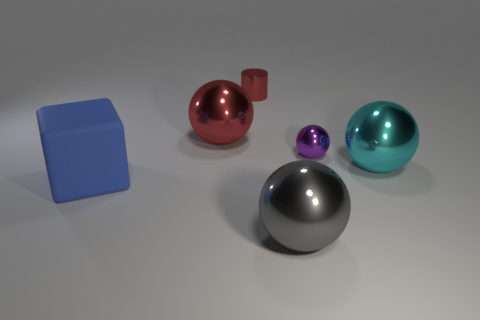Subtract all brown balls. Subtract all cyan cylinders. How many balls are left? 4 Add 1 small cyan matte things. How many objects exist? 7 Subtract all spheres. How many objects are left? 2 Add 6 big red spheres. How many big red spheres are left? 7 Add 3 tiny yellow metal spheres. How many tiny yellow metal spheres exist? 3 Subtract 0 brown cylinders. How many objects are left? 6 Subtract all purple shiny balls. Subtract all big gray objects. How many objects are left? 4 